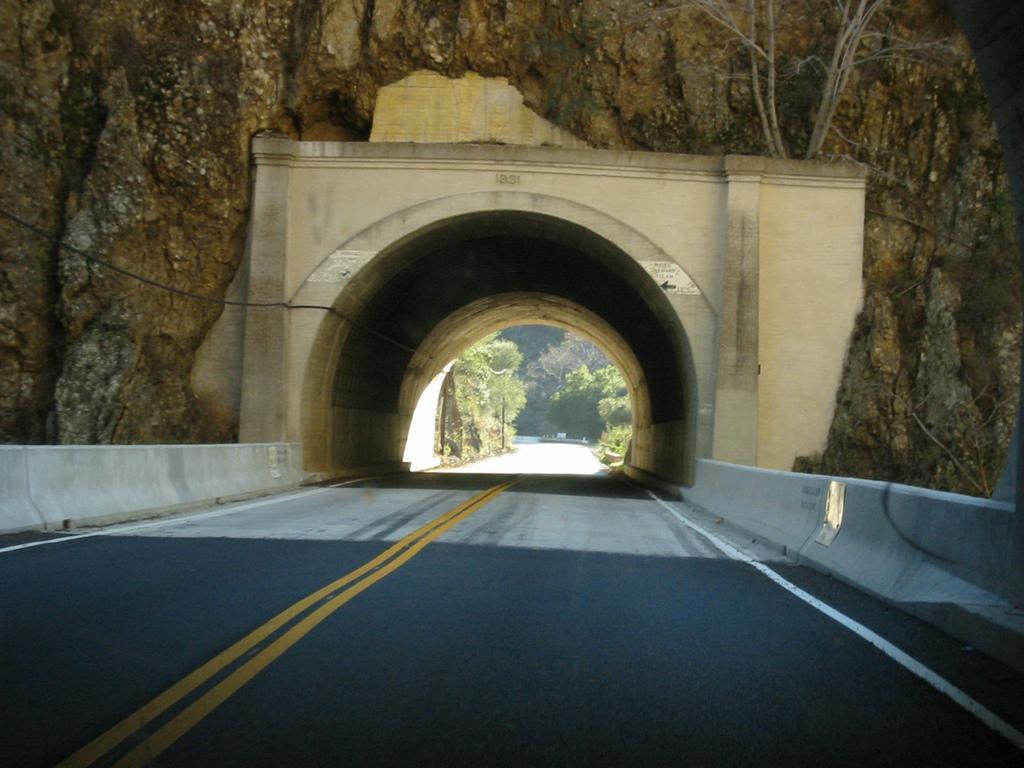How would you summarize this image in a sentence or two? This is an outside view. At the bottom of the image I can see the road and there is a bridge on the road. On the top of the bridge I can see a rock. In the background there are some trees. 